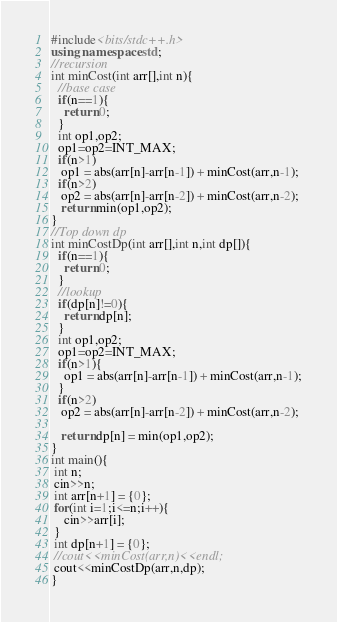Convert code to text. <code><loc_0><loc_0><loc_500><loc_500><_C++_>#include<bits/stdc++.h>
using namespace std;
//recursion
int minCost(int arr[],int n){
  //base case
  if(n==1){
    return 0;
  }
  int op1,op2;
  op1=op2=INT_MAX;
  if(n>1)
   op1 = abs(arr[n]-arr[n-1]) + minCost(arr,n-1);
  if(n>2)
   op2 = abs(arr[n]-arr[n-2]) + minCost(arr,n-2);
   return min(op1,op2);
}
//Top down dp
int minCostDp(int arr[],int n,int dp[]){
  if(n==1){
    return 0;
  }
  //lookup
  if(dp[n]!=0){
    return dp[n];
  }
  int op1,op2;
  op1=op2=INT_MAX;
  if(n>1){
    op1 = abs(arr[n]-arr[n-1]) + minCost(arr,n-1);
  }
  if(n>2)
   op2 = abs(arr[n]-arr[n-2]) + minCost(arr,n-2);

   return dp[n] = min(op1,op2);
}
int main(){
 int n;
 cin>>n;
 int arr[n+1] = {0};
 for(int i=1;i<=n;i++){
    cin>>arr[i];
 }
 int dp[n+1] = {0};
 //cout<<minCost(arr,n)<<endl;
 cout<<minCostDp(arr,n,dp);
}
</code> 